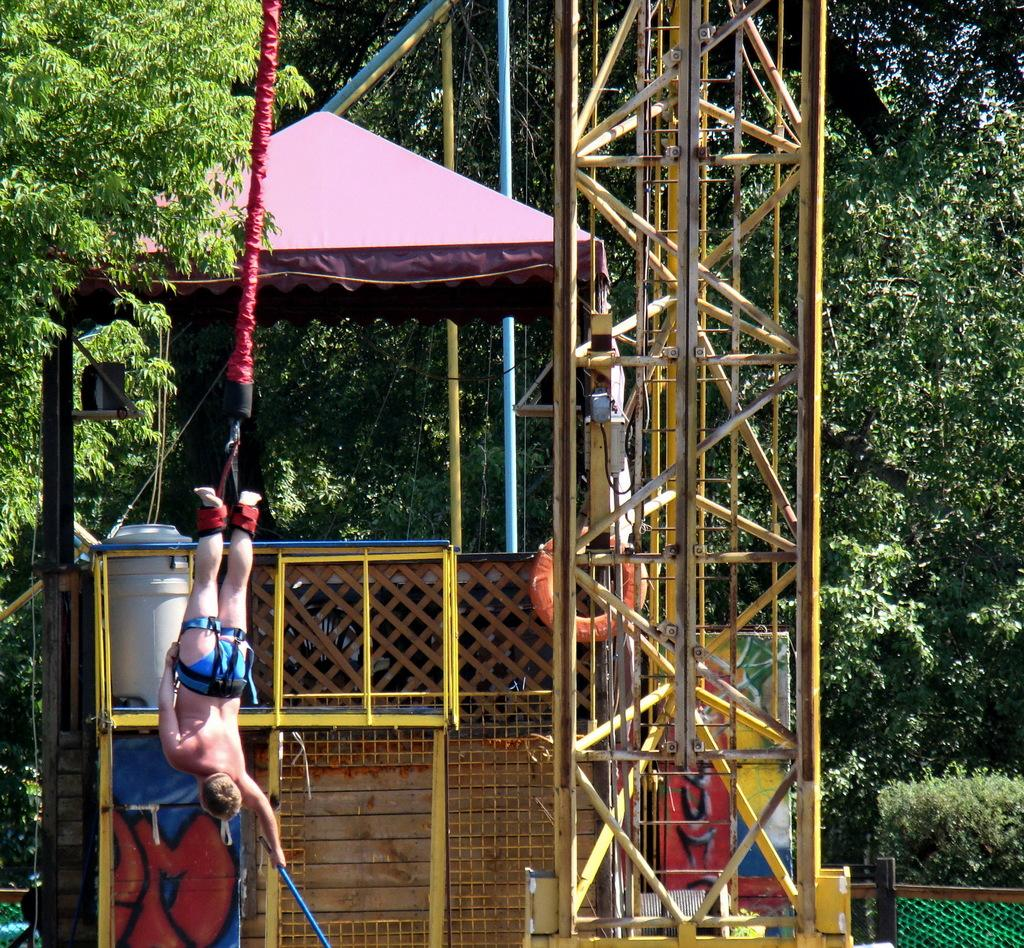What structure is the main focus of the image? There is a tower in the image. What other objects can be seen in the image? There is a tube, a rope, a person, a tree, a tent, and fencing in the image. Can you describe the person in the image? The image only shows a person, but no specific details about the person are provided. What type of vegetation is present in the image? There is a tree in the image. What type of temporary shelter is visible in the image? There is a tent in the image. What type of barrier is present in the image? There is fencing in the image. What is the person's desire in the image? There is no information provided about the person's desires in the image. What range of motion does the rope have in the image? The image only shows a rope, but no specific details about its motion or range are provided. 